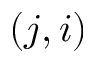<formula> <loc_0><loc_0><loc_500><loc_500>( j , i )</formula> 